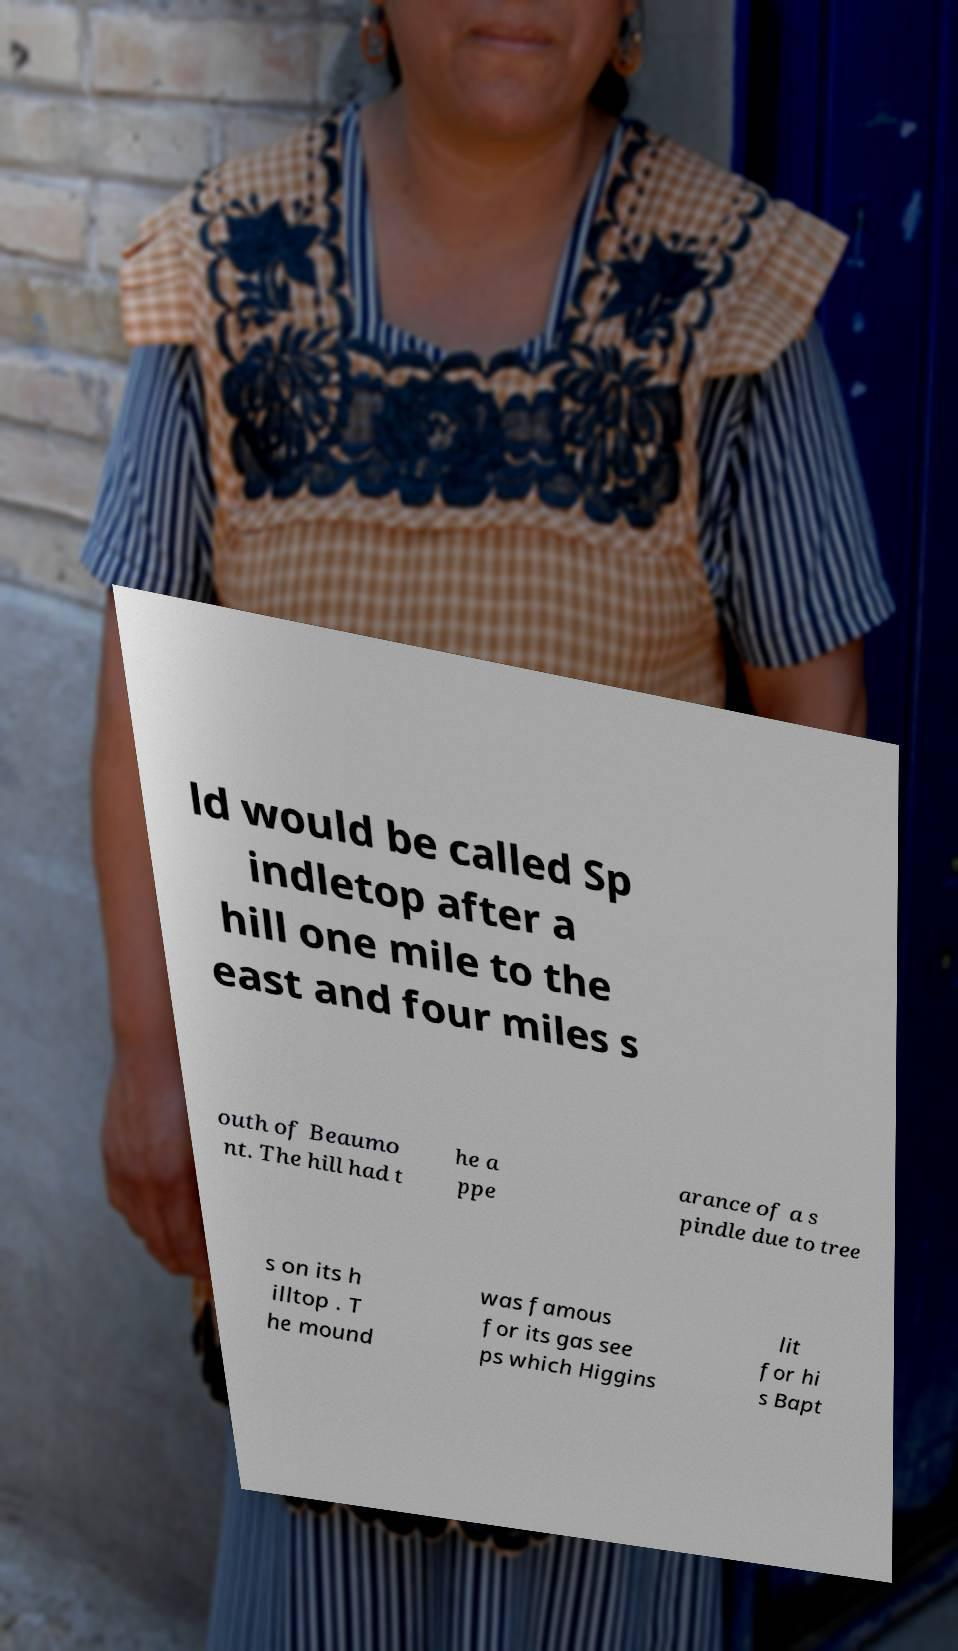There's text embedded in this image that I need extracted. Can you transcribe it verbatim? ld would be called Sp indletop after a hill one mile to the east and four miles s outh of Beaumo nt. The hill had t he a ppe arance of a s pindle due to tree s on its h illtop . T he mound was famous for its gas see ps which Higgins lit for hi s Bapt 